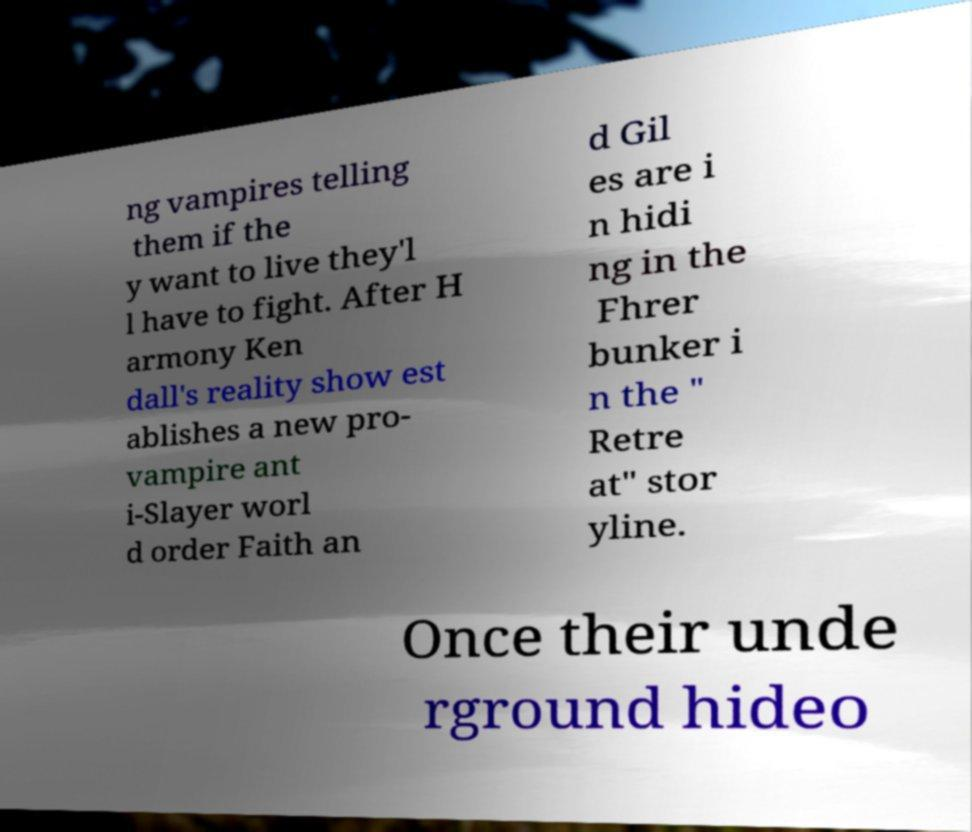What messages or text are displayed in this image? I need them in a readable, typed format. ng vampires telling them if the y want to live they'l l have to fight. After H armony Ken dall's reality show est ablishes a new pro- vampire ant i-Slayer worl d order Faith an d Gil es are i n hidi ng in the Fhrer bunker i n the " Retre at" stor yline. Once their unde rground hideo 